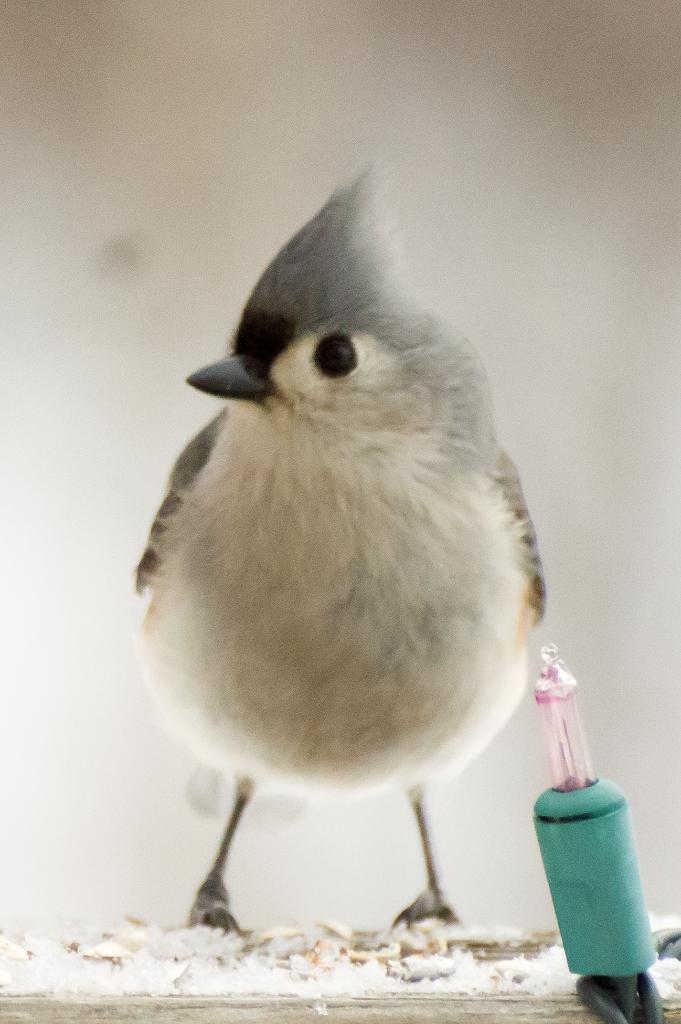What type of animal can be seen in the image? There is a bird in the image. What small object is present in the image? There is a small bulb in the image. Can you describe the objects at the bottom of the image? Unfortunately, the facts provided do not specify the objects at the bottom of the image. How many legs does the maid have in the image? There is no maid present in the image, so it is not possible to determine the number of legs they might have. 